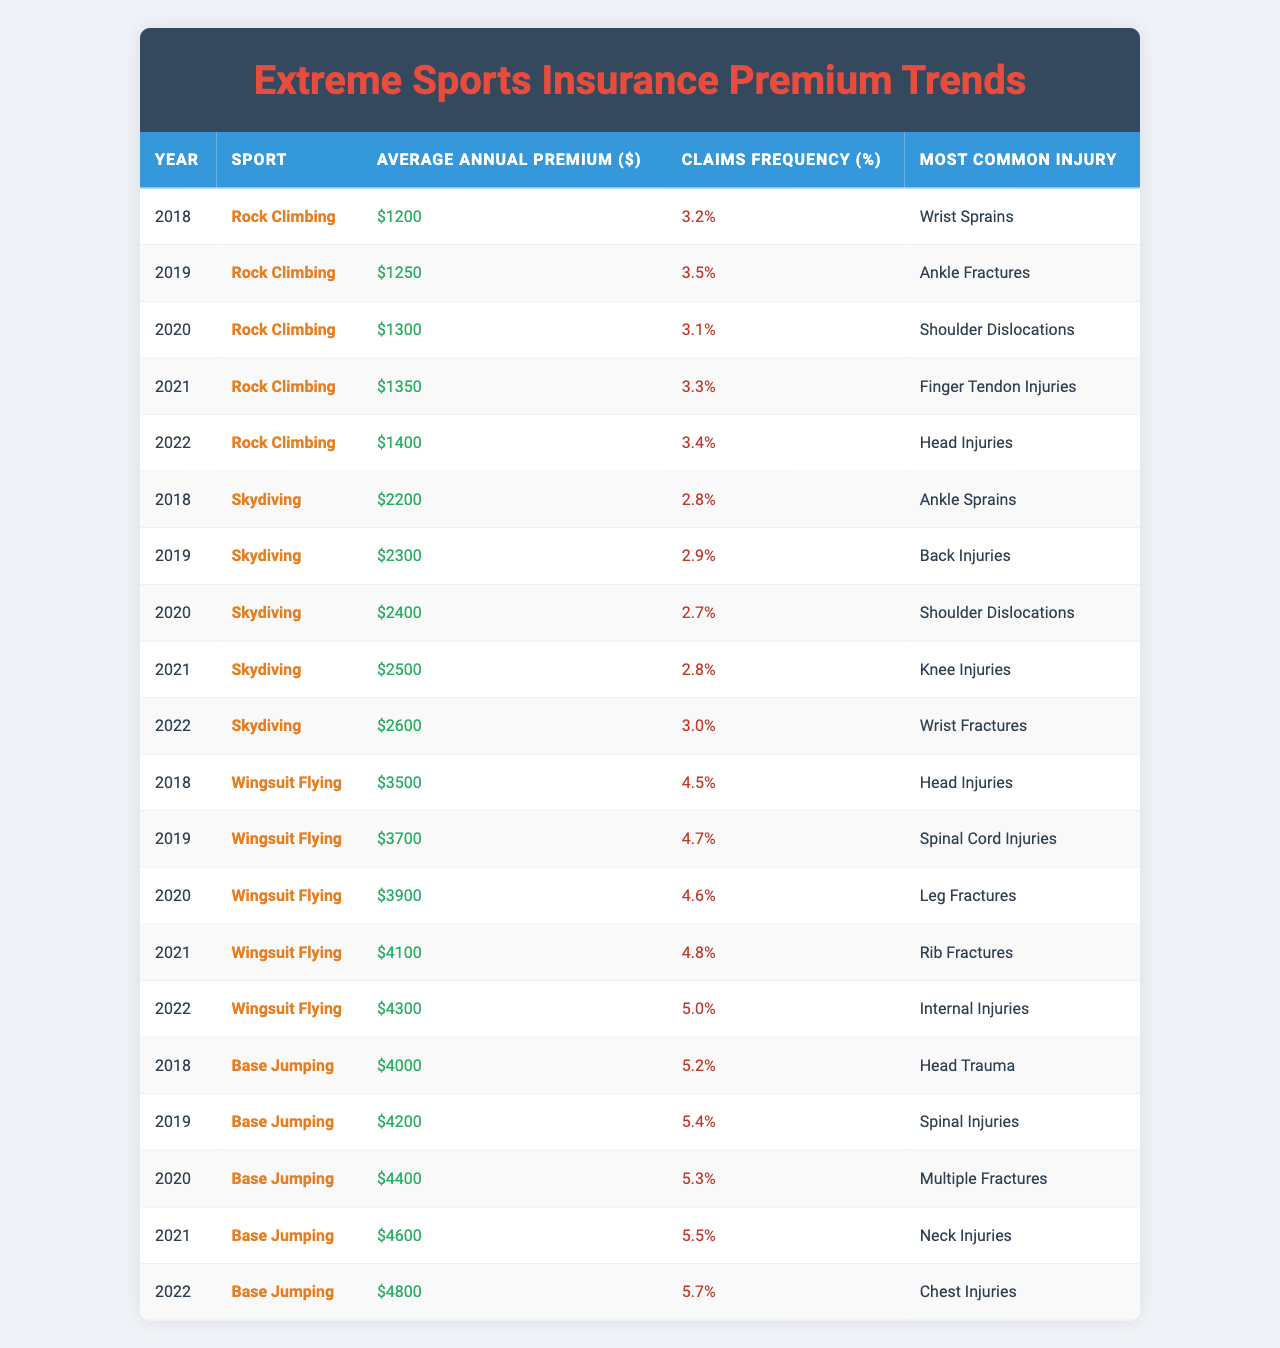What was the average annual premium for rock climbing in 2021? In 2021, the average annual premium for rock climbing is listed in the table and is $1,350.
Answer: $1,350 Which sport had the highest average annual premium in 2022? In 2022, the table shows that wingsuit flying had the highest average annual premium at $4,300 compared to other sports.
Answer: Wingsuit Flying What was the claims frequency for skydiving in 2020? The table indicates that the claims frequency for skydiving in 2020 was 2.7%.
Answer: 2.7% What was the increase in average annual premium for base jumping from 2018 to 2022? The average annual premium for base jumping in 2018 was $4,000 and in 2022 was $4,800. The increase is calculated as $4,800 - $4,000 = $800.
Answer: $800 Did the most common injury for rock climbing change from 2018 to 2022? The most common injury for rock climbing in 2018 was wrist sprains and in 2022 it changed to head injuries, indicating that it did change.
Answer: Yes What is the average annual premium for wingsuit flying across the years listed? The average annual premiums for wingsuit flying from 2018 to 2022 are $3,500, $3,700, $3,900, $4,100, and $4,300. Adding these gives $19,500, and dividing by 5 (the number of years) results in an average of $3,900.
Answer: $3,900 How did the claims frequency for base jumping compare between 2019 and 2022? The claims frequency for base jumping in 2019 was 5.4% and in 2022 it was 5.7%. Comparing these two values shows that the frequency increased from 5.4% to 5.7%.
Answer: Increased Which sport has the most significant jump in average annual premium from 2018 to 2022? Base jumping had an increase from $4,000 in 2018 to $4,800 in 2022, while rock climbing increased from $1,200 to $1,400, and skydiving increased from $2,200 to $2,600. Base jumping's increase of $800 is the largest.
Answer: Base Jumping In how many years did the average annual premium for skydiving increase? Observing the data from 2018 to 2022, the average annual premium for skydiving increased every year. That makes it 4 years of increase (from 2018 to 2022).
Answer: 4 years What can be said about the trend of claims frequency for rock climbing from 2018 to 2022? The table shows the claims frequency for rock climbing fluctuating: 3.2% in 2018, rising to 3.5% in 2019, then dropping to 3.1% in 2020, rising to 3.3% in 2021, and then 3.4% in 2022. Thus, it overall appears to fluctuate with no clear upward or downward trend.
Answer: Fluctuates without a clear trend 